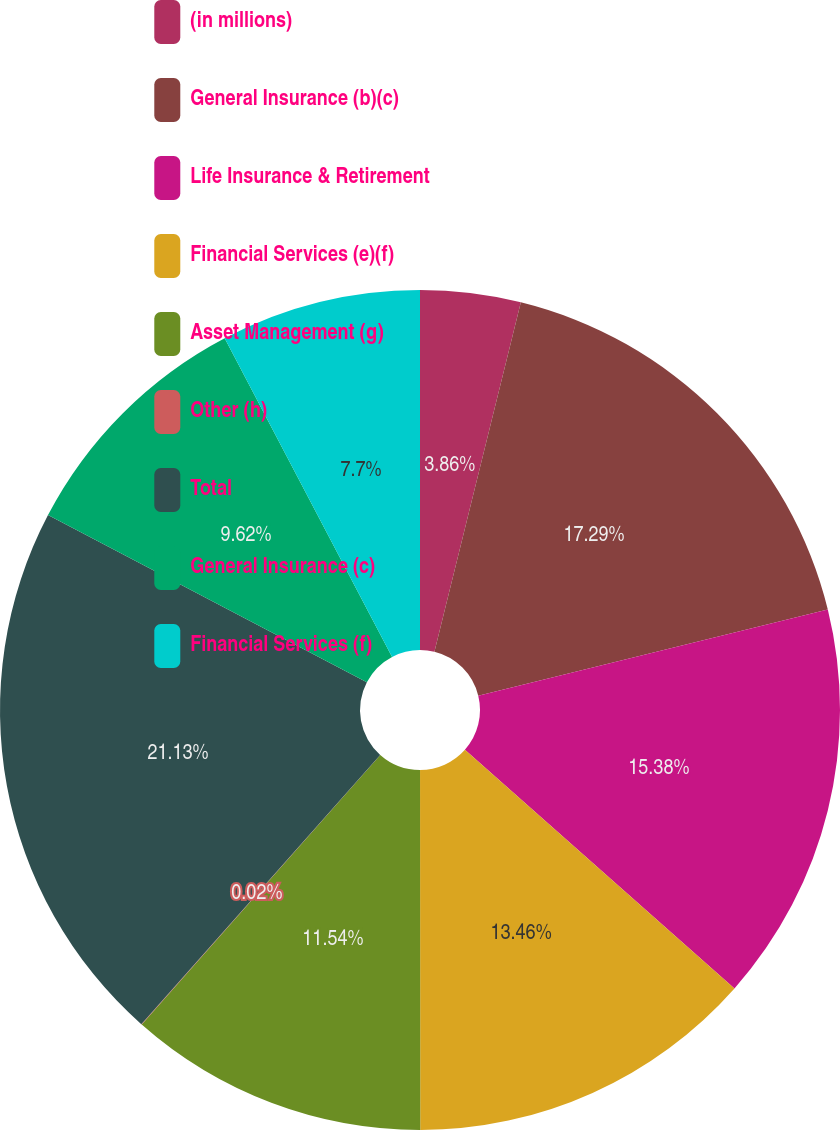<chart> <loc_0><loc_0><loc_500><loc_500><pie_chart><fcel>(in millions)<fcel>General Insurance (b)(c)<fcel>Life Insurance & Retirement<fcel>Financial Services (e)(f)<fcel>Asset Management (g)<fcel>Other (h)<fcel>Total<fcel>General Insurance (c)<fcel>Financial Services (f)<nl><fcel>3.86%<fcel>17.3%<fcel>15.38%<fcel>13.46%<fcel>11.54%<fcel>0.02%<fcel>21.14%<fcel>9.62%<fcel>7.7%<nl></chart> 